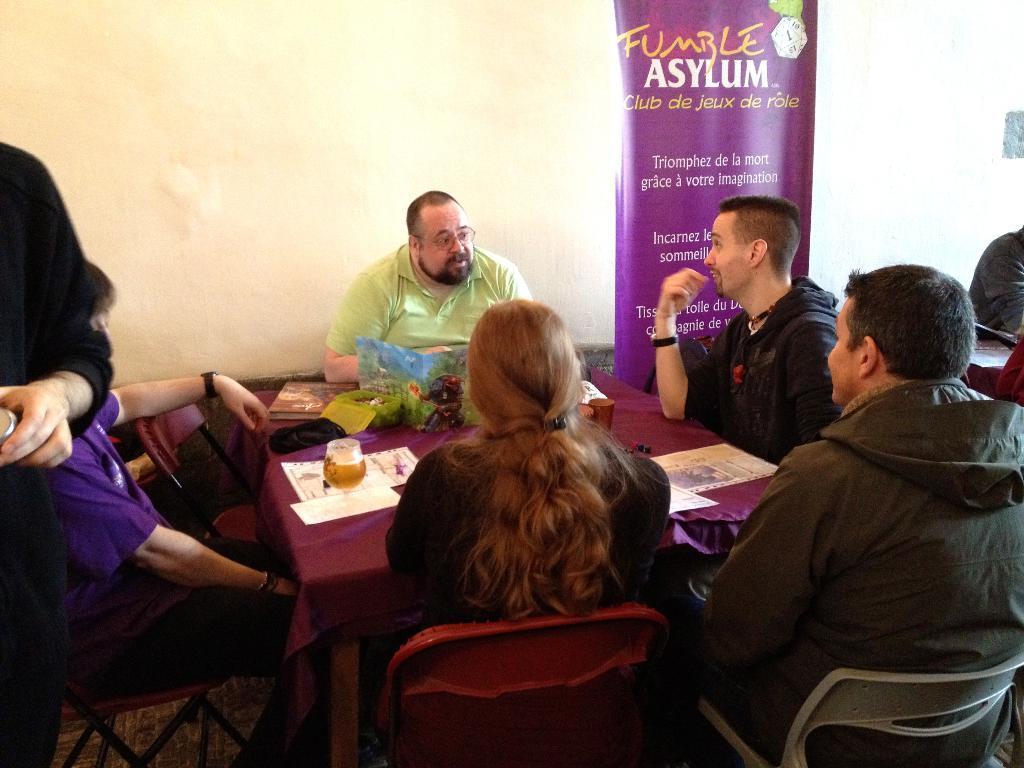Please provide a concise description of this image. Here we can see a group of people are sitting on the chair, and in front here is the table and glass and papers and some objects on it, and here is the hoarding, and at back here is the wall. 